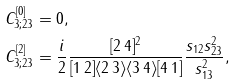Convert formula to latex. <formula><loc_0><loc_0><loc_500><loc_500>C _ { 3 ; 2 3 } ^ { [ 0 ] } & = 0 , \\ C _ { 3 ; 2 3 } ^ { [ 2 ] } & = \frac { i } { 2 } \frac { [ 2 \, 4 ] ^ { 2 } } { [ 1 \, 2 ] \langle 2 \, 3 \rangle \langle 3 \, 4 \rangle [ 4 \, 1 ] } \frac { s _ { 1 2 } s _ { 2 3 } ^ { 2 } } { s _ { 1 3 } ^ { 2 } } ,</formula> 